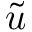Convert formula to latex. <formula><loc_0><loc_0><loc_500><loc_500>\tilde { u }</formula> 